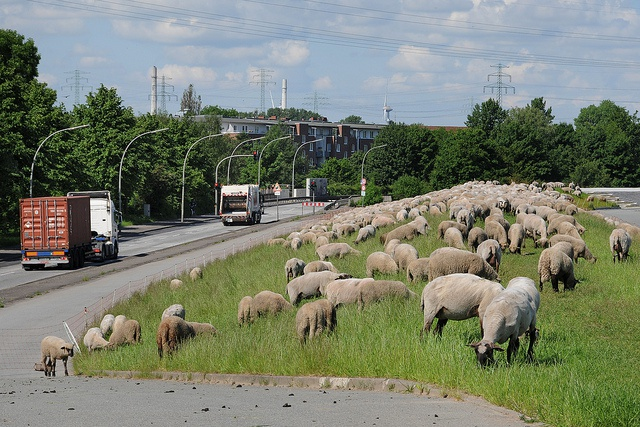Describe the objects in this image and their specific colors. I can see sheep in darkgray, gray, and tan tones, truck in darkgray, black, lightgray, brown, and gray tones, cow in darkgray, black, and gray tones, sheep in darkgray, tan, and black tones, and cow in darkgray, tan, and black tones in this image. 